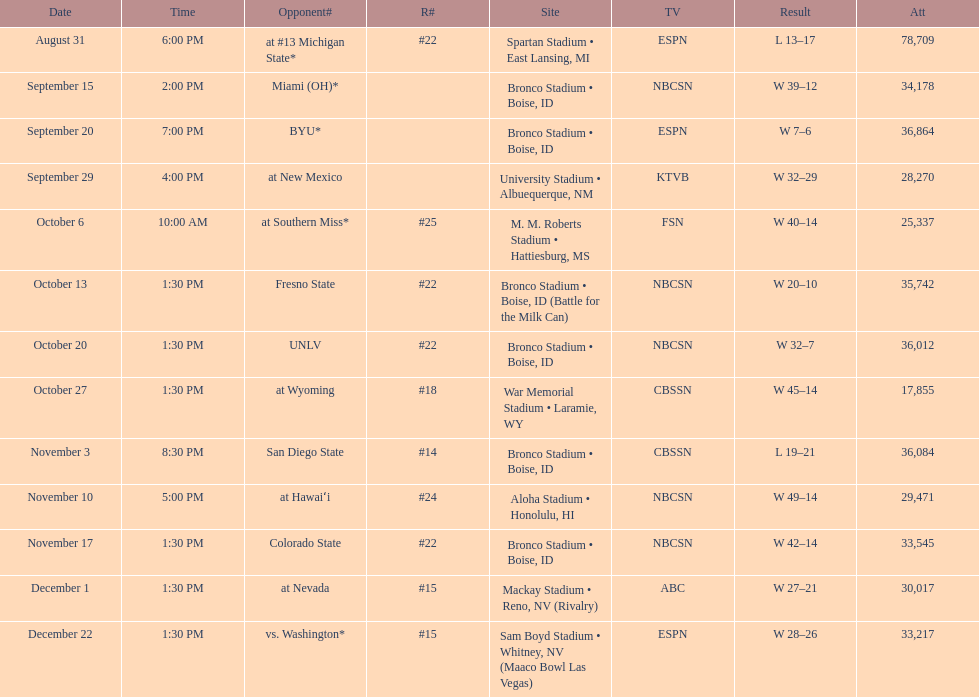What are all of the rankings? #22, , , , #25, #22, #22, #18, #14, #24, #22, #15, #15. Which of them was the best position? #14. 